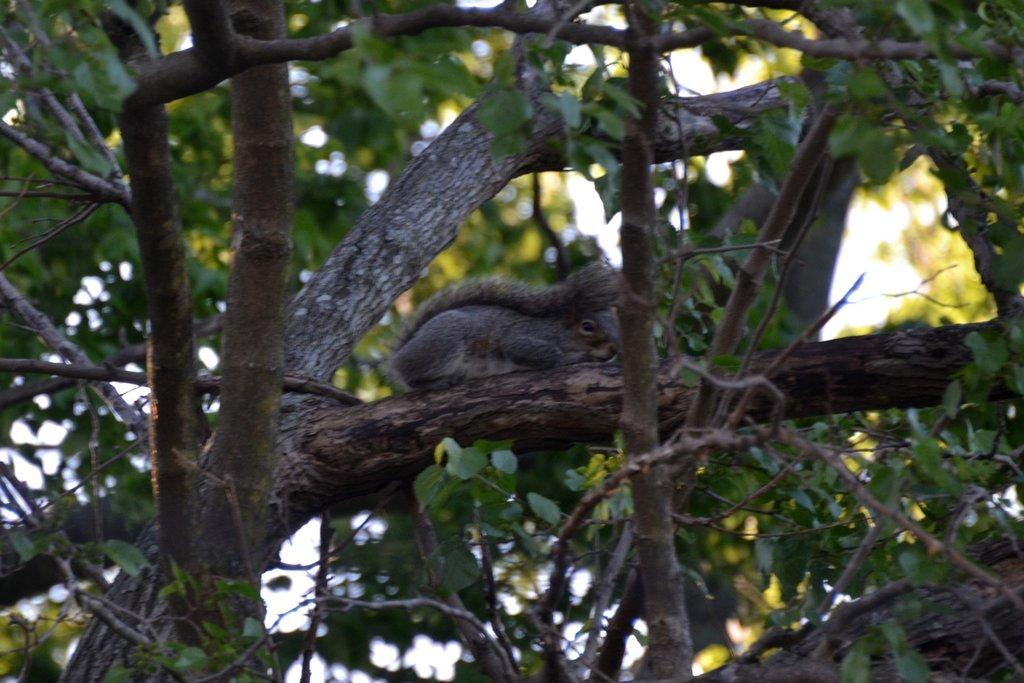What type of animal is in the image? There is a black squirrel in the image. Where is the squirrel located? The squirrel is on a tree branch. What can be seen in the background of the image? There are trees visible in the background of the image. What is present on the right side of the image? Leaves are present on the right side of the image. What type of coach is present in the image? There is no coach present in the image; it features a black squirrel on a tree branch. Are there any slaves visible in the image? There are no slaves present in the image; it features a black squirrel on a tree branch. 